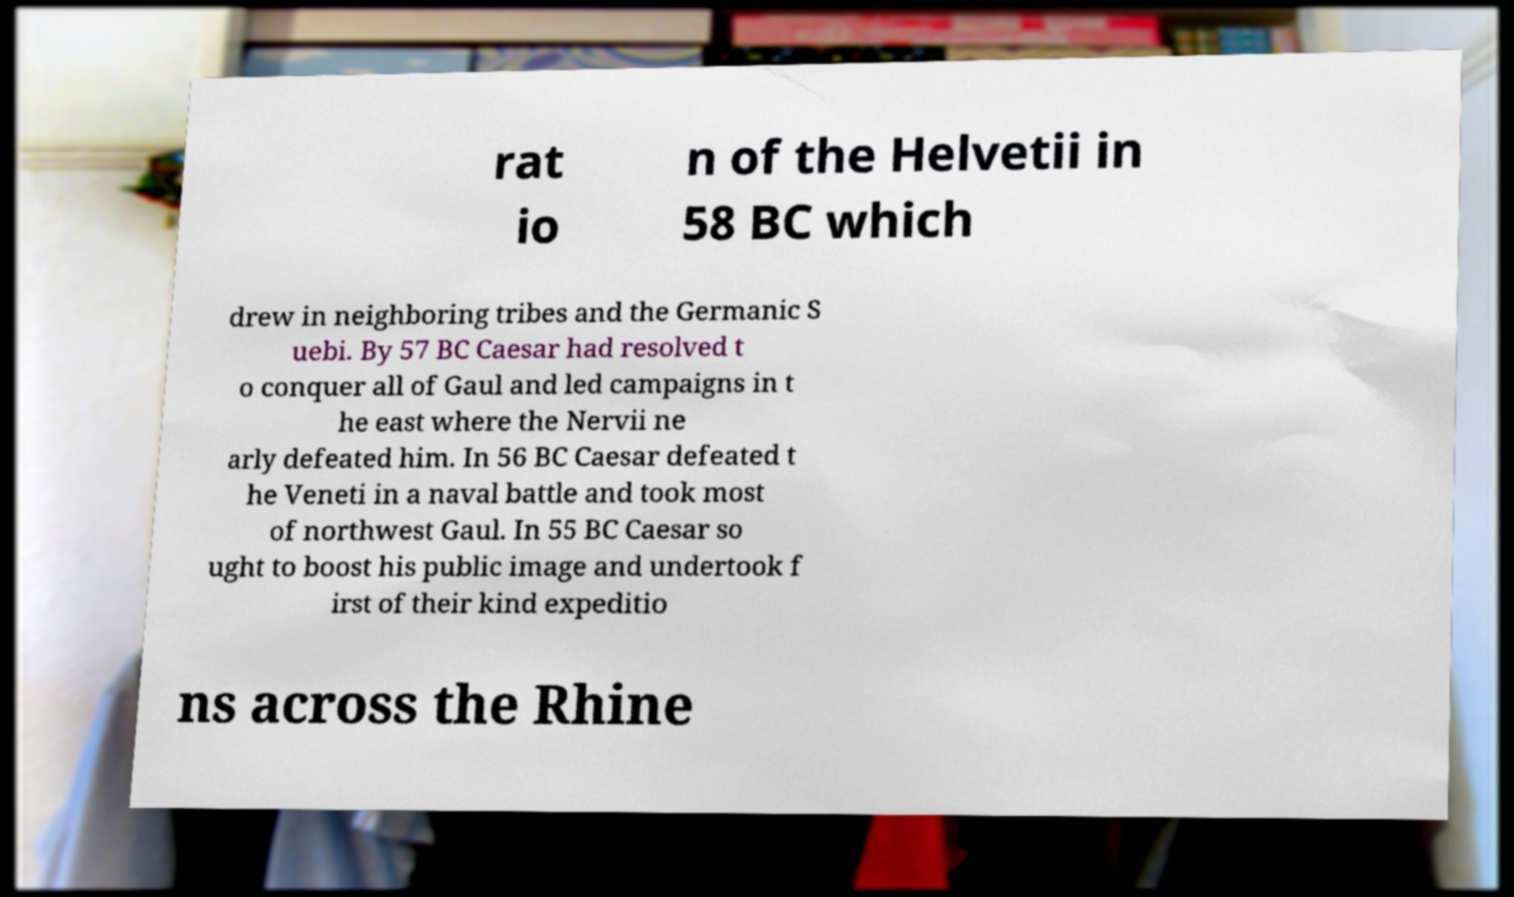Could you assist in decoding the text presented in this image and type it out clearly? rat io n of the Helvetii in 58 BC which drew in neighboring tribes and the Germanic S uebi. By 57 BC Caesar had resolved t o conquer all of Gaul and led campaigns in t he east where the Nervii ne arly defeated him. In 56 BC Caesar defeated t he Veneti in a naval battle and took most of northwest Gaul. In 55 BC Caesar so ught to boost his public image and undertook f irst of their kind expeditio ns across the Rhine 